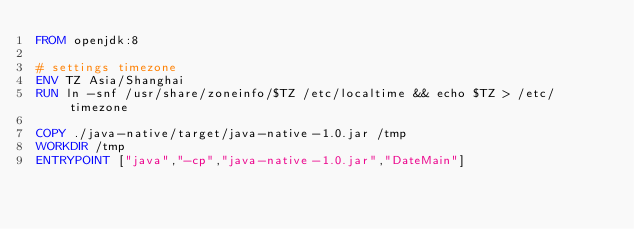<code> <loc_0><loc_0><loc_500><loc_500><_Dockerfile_>FROM openjdk:8

# settings timezone
ENV TZ Asia/Shanghai
RUN ln -snf /usr/share/zoneinfo/$TZ /etc/localtime && echo $TZ > /etc/timezone

COPY ./java-native/target/java-native-1.0.jar /tmp
WORKDIR /tmp
ENTRYPOINT ["java","-cp","java-native-1.0.jar","DateMain"]</code> 